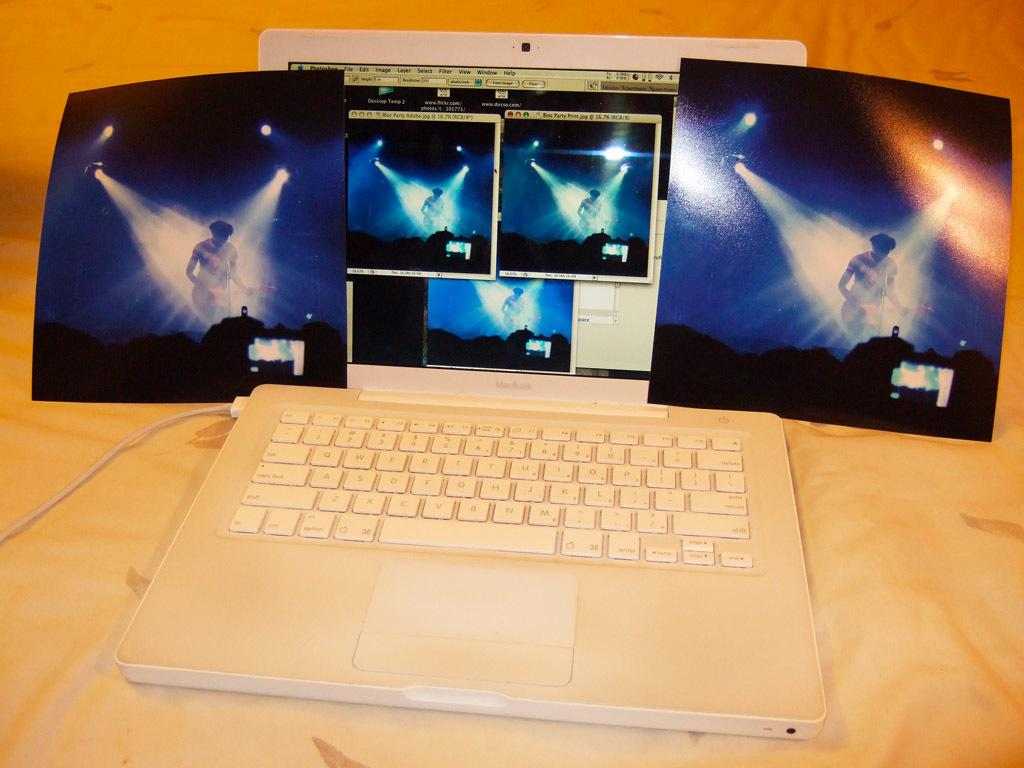<image>
Provide a brief description of the given image. A white laptop with the word "Macbook" on it. 